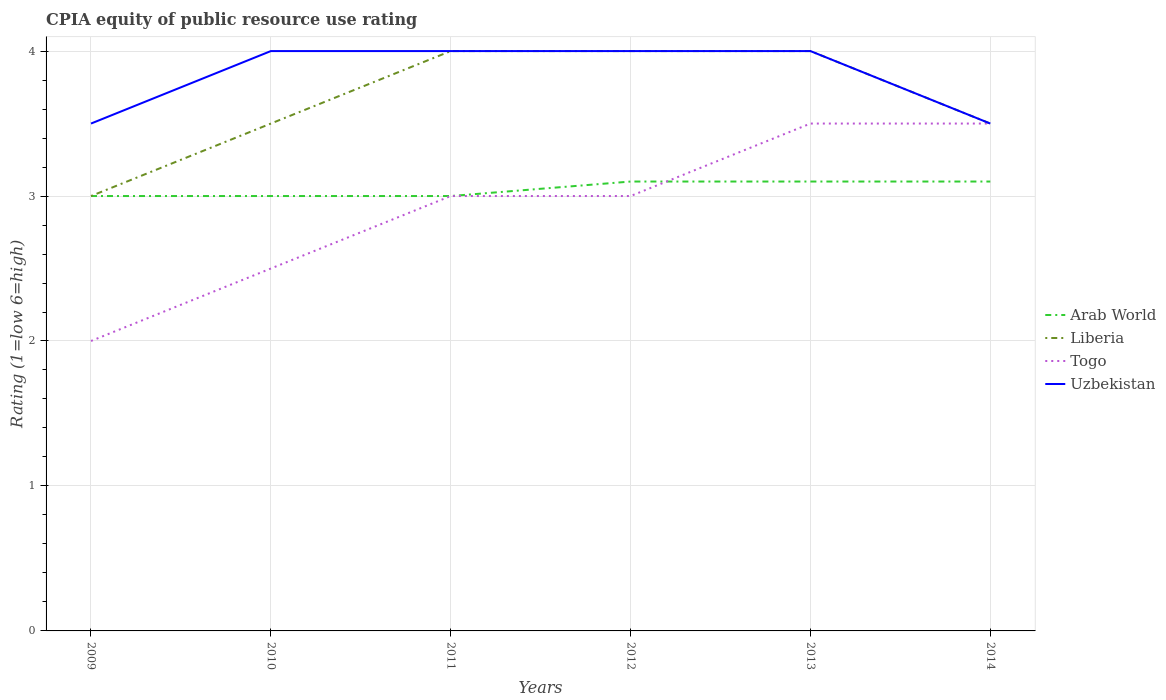How many different coloured lines are there?
Your response must be concise. 4. Does the line corresponding to Arab World intersect with the line corresponding to Uzbekistan?
Give a very brief answer. No. Is the number of lines equal to the number of legend labels?
Provide a short and direct response. Yes. In which year was the CPIA rating in Arab World maximum?
Keep it short and to the point. 2009. What is the total CPIA rating in Arab World in the graph?
Provide a succinct answer. -0.1. What is the difference between the highest and the second highest CPIA rating in Arab World?
Make the answer very short. 0.1. Is the CPIA rating in Liberia strictly greater than the CPIA rating in Togo over the years?
Give a very brief answer. No. How many lines are there?
Your answer should be compact. 4. What is the difference between two consecutive major ticks on the Y-axis?
Provide a succinct answer. 1. Are the values on the major ticks of Y-axis written in scientific E-notation?
Your response must be concise. No. Does the graph contain any zero values?
Offer a terse response. No. Does the graph contain grids?
Give a very brief answer. Yes. How many legend labels are there?
Give a very brief answer. 4. How are the legend labels stacked?
Provide a short and direct response. Vertical. What is the title of the graph?
Provide a succinct answer. CPIA equity of public resource use rating. Does "El Salvador" appear as one of the legend labels in the graph?
Give a very brief answer. No. What is the label or title of the Y-axis?
Your answer should be compact. Rating (1=low 6=high). What is the Rating (1=low 6=high) in Arab World in 2009?
Make the answer very short. 3. What is the Rating (1=low 6=high) of Liberia in 2009?
Make the answer very short. 3. What is the Rating (1=low 6=high) in Arab World in 2010?
Give a very brief answer. 3. What is the Rating (1=low 6=high) of Liberia in 2010?
Your response must be concise. 3.5. What is the Rating (1=low 6=high) in Togo in 2010?
Make the answer very short. 2.5. What is the Rating (1=low 6=high) of Liberia in 2011?
Offer a terse response. 4. What is the Rating (1=low 6=high) in Uzbekistan in 2011?
Make the answer very short. 4. What is the Rating (1=low 6=high) in Arab World in 2012?
Ensure brevity in your answer.  3.1. What is the Rating (1=low 6=high) of Togo in 2012?
Make the answer very short. 3. What is the Rating (1=low 6=high) of Arab World in 2013?
Offer a terse response. 3.1. What is the Rating (1=low 6=high) of Liberia in 2013?
Keep it short and to the point. 4. What is the Rating (1=low 6=high) of Liberia in 2014?
Provide a succinct answer. 3.5. What is the Rating (1=low 6=high) of Uzbekistan in 2014?
Offer a very short reply. 3.5. Across all years, what is the maximum Rating (1=low 6=high) of Liberia?
Offer a very short reply. 4. Across all years, what is the minimum Rating (1=low 6=high) of Arab World?
Offer a very short reply. 3. Across all years, what is the minimum Rating (1=low 6=high) in Togo?
Your answer should be very brief. 2. Across all years, what is the minimum Rating (1=low 6=high) in Uzbekistan?
Offer a terse response. 3.5. What is the total Rating (1=low 6=high) of Arab World in the graph?
Your answer should be compact. 18.3. What is the total Rating (1=low 6=high) of Liberia in the graph?
Your answer should be very brief. 22. What is the difference between the Rating (1=low 6=high) in Liberia in 2009 and that in 2010?
Your answer should be compact. -0.5. What is the difference between the Rating (1=low 6=high) in Togo in 2009 and that in 2010?
Keep it short and to the point. -0.5. What is the difference between the Rating (1=low 6=high) of Uzbekistan in 2009 and that in 2010?
Your answer should be compact. -0.5. What is the difference between the Rating (1=low 6=high) in Liberia in 2009 and that in 2011?
Offer a very short reply. -1. What is the difference between the Rating (1=low 6=high) in Arab World in 2009 and that in 2012?
Give a very brief answer. -0.1. What is the difference between the Rating (1=low 6=high) of Liberia in 2009 and that in 2012?
Make the answer very short. -1. What is the difference between the Rating (1=low 6=high) in Uzbekistan in 2009 and that in 2012?
Provide a short and direct response. -0.5. What is the difference between the Rating (1=low 6=high) in Arab World in 2009 and that in 2013?
Provide a short and direct response. -0.1. What is the difference between the Rating (1=low 6=high) of Liberia in 2009 and that in 2014?
Make the answer very short. -0.5. What is the difference between the Rating (1=low 6=high) of Togo in 2009 and that in 2014?
Give a very brief answer. -1.5. What is the difference between the Rating (1=low 6=high) of Arab World in 2010 and that in 2011?
Provide a succinct answer. 0. What is the difference between the Rating (1=low 6=high) of Liberia in 2010 and that in 2011?
Make the answer very short. -0.5. What is the difference between the Rating (1=low 6=high) in Togo in 2010 and that in 2011?
Your answer should be very brief. -0.5. What is the difference between the Rating (1=low 6=high) of Uzbekistan in 2010 and that in 2011?
Your response must be concise. 0. What is the difference between the Rating (1=low 6=high) of Liberia in 2010 and that in 2012?
Provide a succinct answer. -0.5. What is the difference between the Rating (1=low 6=high) in Togo in 2010 and that in 2012?
Provide a short and direct response. -0.5. What is the difference between the Rating (1=low 6=high) in Uzbekistan in 2010 and that in 2012?
Your answer should be compact. 0. What is the difference between the Rating (1=low 6=high) in Arab World in 2010 and that in 2013?
Provide a short and direct response. -0.1. What is the difference between the Rating (1=low 6=high) in Liberia in 2010 and that in 2013?
Keep it short and to the point. -0.5. What is the difference between the Rating (1=low 6=high) of Uzbekistan in 2010 and that in 2013?
Offer a terse response. 0. What is the difference between the Rating (1=low 6=high) in Arab World in 2010 and that in 2014?
Keep it short and to the point. -0.1. What is the difference between the Rating (1=low 6=high) in Uzbekistan in 2010 and that in 2014?
Ensure brevity in your answer.  0.5. What is the difference between the Rating (1=low 6=high) of Togo in 2011 and that in 2012?
Provide a succinct answer. 0. What is the difference between the Rating (1=low 6=high) of Liberia in 2011 and that in 2013?
Provide a succinct answer. 0. What is the difference between the Rating (1=low 6=high) of Togo in 2011 and that in 2013?
Keep it short and to the point. -0.5. What is the difference between the Rating (1=low 6=high) of Arab World in 2011 and that in 2014?
Offer a very short reply. -0.1. What is the difference between the Rating (1=low 6=high) in Arab World in 2012 and that in 2013?
Your answer should be very brief. 0. What is the difference between the Rating (1=low 6=high) of Liberia in 2012 and that in 2013?
Offer a terse response. 0. What is the difference between the Rating (1=low 6=high) of Togo in 2012 and that in 2013?
Your response must be concise. -0.5. What is the difference between the Rating (1=low 6=high) of Arab World in 2012 and that in 2014?
Your response must be concise. 0. What is the difference between the Rating (1=low 6=high) in Liberia in 2012 and that in 2014?
Make the answer very short. 0.5. What is the difference between the Rating (1=low 6=high) of Togo in 2012 and that in 2014?
Provide a succinct answer. -0.5. What is the difference between the Rating (1=low 6=high) of Arab World in 2013 and that in 2014?
Your answer should be very brief. 0. What is the difference between the Rating (1=low 6=high) of Togo in 2013 and that in 2014?
Provide a short and direct response. 0. What is the difference between the Rating (1=low 6=high) of Arab World in 2009 and the Rating (1=low 6=high) of Liberia in 2011?
Ensure brevity in your answer.  -1. What is the difference between the Rating (1=low 6=high) of Arab World in 2009 and the Rating (1=low 6=high) of Uzbekistan in 2011?
Make the answer very short. -1. What is the difference between the Rating (1=low 6=high) of Liberia in 2009 and the Rating (1=low 6=high) of Togo in 2011?
Offer a terse response. 0. What is the difference between the Rating (1=low 6=high) of Togo in 2009 and the Rating (1=low 6=high) of Uzbekistan in 2011?
Provide a short and direct response. -2. What is the difference between the Rating (1=low 6=high) in Arab World in 2009 and the Rating (1=low 6=high) in Togo in 2012?
Your answer should be very brief. 0. What is the difference between the Rating (1=low 6=high) in Arab World in 2009 and the Rating (1=low 6=high) in Uzbekistan in 2012?
Offer a very short reply. -1. What is the difference between the Rating (1=low 6=high) in Liberia in 2009 and the Rating (1=low 6=high) in Uzbekistan in 2012?
Your answer should be compact. -1. What is the difference between the Rating (1=low 6=high) of Togo in 2009 and the Rating (1=low 6=high) of Uzbekistan in 2012?
Ensure brevity in your answer.  -2. What is the difference between the Rating (1=low 6=high) in Arab World in 2009 and the Rating (1=low 6=high) in Liberia in 2013?
Ensure brevity in your answer.  -1. What is the difference between the Rating (1=low 6=high) in Liberia in 2009 and the Rating (1=low 6=high) in Togo in 2013?
Your answer should be very brief. -0.5. What is the difference between the Rating (1=low 6=high) of Liberia in 2009 and the Rating (1=low 6=high) of Uzbekistan in 2013?
Offer a very short reply. -1. What is the difference between the Rating (1=low 6=high) of Togo in 2009 and the Rating (1=low 6=high) of Uzbekistan in 2013?
Give a very brief answer. -2. What is the difference between the Rating (1=low 6=high) in Arab World in 2009 and the Rating (1=low 6=high) in Liberia in 2014?
Your answer should be compact. -0.5. What is the difference between the Rating (1=low 6=high) of Arab World in 2009 and the Rating (1=low 6=high) of Togo in 2014?
Your response must be concise. -0.5. What is the difference between the Rating (1=low 6=high) of Arab World in 2009 and the Rating (1=low 6=high) of Uzbekistan in 2014?
Make the answer very short. -0.5. What is the difference between the Rating (1=low 6=high) in Arab World in 2010 and the Rating (1=low 6=high) in Togo in 2011?
Provide a succinct answer. 0. What is the difference between the Rating (1=low 6=high) in Arab World in 2010 and the Rating (1=low 6=high) in Uzbekistan in 2011?
Keep it short and to the point. -1. What is the difference between the Rating (1=low 6=high) of Liberia in 2010 and the Rating (1=low 6=high) of Uzbekistan in 2011?
Provide a short and direct response. -0.5. What is the difference between the Rating (1=low 6=high) of Arab World in 2010 and the Rating (1=low 6=high) of Liberia in 2012?
Offer a very short reply. -1. What is the difference between the Rating (1=low 6=high) in Arab World in 2010 and the Rating (1=low 6=high) in Uzbekistan in 2012?
Your answer should be compact. -1. What is the difference between the Rating (1=low 6=high) in Togo in 2010 and the Rating (1=low 6=high) in Uzbekistan in 2012?
Keep it short and to the point. -1.5. What is the difference between the Rating (1=low 6=high) of Liberia in 2010 and the Rating (1=low 6=high) of Uzbekistan in 2013?
Keep it short and to the point. -0.5. What is the difference between the Rating (1=low 6=high) in Arab World in 2010 and the Rating (1=low 6=high) in Liberia in 2014?
Your answer should be compact. -0.5. What is the difference between the Rating (1=low 6=high) of Arab World in 2010 and the Rating (1=low 6=high) of Uzbekistan in 2014?
Make the answer very short. -0.5. What is the difference between the Rating (1=low 6=high) of Liberia in 2010 and the Rating (1=low 6=high) of Uzbekistan in 2014?
Your response must be concise. 0. What is the difference between the Rating (1=low 6=high) in Togo in 2010 and the Rating (1=low 6=high) in Uzbekistan in 2014?
Your answer should be very brief. -1. What is the difference between the Rating (1=low 6=high) of Arab World in 2011 and the Rating (1=low 6=high) of Togo in 2012?
Offer a very short reply. 0. What is the difference between the Rating (1=low 6=high) of Liberia in 2011 and the Rating (1=low 6=high) of Togo in 2012?
Ensure brevity in your answer.  1. What is the difference between the Rating (1=low 6=high) of Liberia in 2011 and the Rating (1=low 6=high) of Uzbekistan in 2012?
Make the answer very short. 0. What is the difference between the Rating (1=low 6=high) in Arab World in 2011 and the Rating (1=low 6=high) in Togo in 2013?
Provide a short and direct response. -0.5. What is the difference between the Rating (1=low 6=high) of Arab World in 2011 and the Rating (1=low 6=high) of Liberia in 2014?
Offer a terse response. -0.5. What is the difference between the Rating (1=low 6=high) in Arab World in 2011 and the Rating (1=low 6=high) in Uzbekistan in 2014?
Offer a terse response. -0.5. What is the difference between the Rating (1=low 6=high) in Liberia in 2011 and the Rating (1=low 6=high) in Uzbekistan in 2014?
Provide a succinct answer. 0.5. What is the difference between the Rating (1=low 6=high) of Togo in 2012 and the Rating (1=low 6=high) of Uzbekistan in 2013?
Keep it short and to the point. -1. What is the difference between the Rating (1=low 6=high) in Arab World in 2012 and the Rating (1=low 6=high) in Liberia in 2014?
Your answer should be very brief. -0.4. What is the difference between the Rating (1=low 6=high) in Arab World in 2012 and the Rating (1=low 6=high) in Uzbekistan in 2014?
Offer a very short reply. -0.4. What is the difference between the Rating (1=low 6=high) in Arab World in 2013 and the Rating (1=low 6=high) in Togo in 2014?
Your answer should be very brief. -0.4. What is the difference between the Rating (1=low 6=high) of Arab World in 2013 and the Rating (1=low 6=high) of Uzbekistan in 2014?
Offer a very short reply. -0.4. What is the difference between the Rating (1=low 6=high) of Liberia in 2013 and the Rating (1=low 6=high) of Uzbekistan in 2014?
Provide a succinct answer. 0.5. What is the difference between the Rating (1=low 6=high) of Togo in 2013 and the Rating (1=low 6=high) of Uzbekistan in 2014?
Keep it short and to the point. 0. What is the average Rating (1=low 6=high) of Arab World per year?
Give a very brief answer. 3.05. What is the average Rating (1=low 6=high) of Liberia per year?
Ensure brevity in your answer.  3.67. What is the average Rating (1=low 6=high) in Togo per year?
Your answer should be very brief. 2.92. What is the average Rating (1=low 6=high) in Uzbekistan per year?
Provide a short and direct response. 3.83. In the year 2009, what is the difference between the Rating (1=low 6=high) in Arab World and Rating (1=low 6=high) in Uzbekistan?
Ensure brevity in your answer.  -0.5. In the year 2009, what is the difference between the Rating (1=low 6=high) in Liberia and Rating (1=low 6=high) in Togo?
Ensure brevity in your answer.  1. In the year 2010, what is the difference between the Rating (1=low 6=high) of Arab World and Rating (1=low 6=high) of Togo?
Ensure brevity in your answer.  0.5. In the year 2010, what is the difference between the Rating (1=low 6=high) in Arab World and Rating (1=low 6=high) in Uzbekistan?
Keep it short and to the point. -1. In the year 2010, what is the difference between the Rating (1=low 6=high) of Liberia and Rating (1=low 6=high) of Uzbekistan?
Your response must be concise. -0.5. In the year 2011, what is the difference between the Rating (1=low 6=high) in Liberia and Rating (1=low 6=high) in Togo?
Give a very brief answer. 1. In the year 2011, what is the difference between the Rating (1=low 6=high) in Liberia and Rating (1=low 6=high) in Uzbekistan?
Make the answer very short. 0. In the year 2012, what is the difference between the Rating (1=low 6=high) in Arab World and Rating (1=low 6=high) in Liberia?
Ensure brevity in your answer.  -0.9. In the year 2012, what is the difference between the Rating (1=low 6=high) in Arab World and Rating (1=low 6=high) in Togo?
Keep it short and to the point. 0.1. In the year 2012, what is the difference between the Rating (1=low 6=high) of Togo and Rating (1=low 6=high) of Uzbekistan?
Your answer should be very brief. -1. In the year 2013, what is the difference between the Rating (1=low 6=high) of Arab World and Rating (1=low 6=high) of Togo?
Provide a short and direct response. -0.4. In the year 2013, what is the difference between the Rating (1=low 6=high) in Arab World and Rating (1=low 6=high) in Uzbekistan?
Your response must be concise. -0.9. In the year 2013, what is the difference between the Rating (1=low 6=high) of Liberia and Rating (1=low 6=high) of Togo?
Give a very brief answer. 0.5. In the year 2013, what is the difference between the Rating (1=low 6=high) of Togo and Rating (1=low 6=high) of Uzbekistan?
Ensure brevity in your answer.  -0.5. In the year 2014, what is the difference between the Rating (1=low 6=high) in Arab World and Rating (1=low 6=high) in Liberia?
Offer a very short reply. -0.4. In the year 2014, what is the difference between the Rating (1=low 6=high) in Togo and Rating (1=low 6=high) in Uzbekistan?
Your response must be concise. 0. What is the ratio of the Rating (1=low 6=high) in Arab World in 2009 to that in 2010?
Your answer should be very brief. 1. What is the ratio of the Rating (1=low 6=high) of Liberia in 2009 to that in 2010?
Offer a very short reply. 0.86. What is the ratio of the Rating (1=low 6=high) in Togo in 2009 to that in 2010?
Ensure brevity in your answer.  0.8. What is the ratio of the Rating (1=low 6=high) of Uzbekistan in 2009 to that in 2010?
Your answer should be very brief. 0.88. What is the ratio of the Rating (1=low 6=high) in Arab World in 2009 to that in 2011?
Keep it short and to the point. 1. What is the ratio of the Rating (1=low 6=high) in Liberia in 2009 to that in 2011?
Offer a terse response. 0.75. What is the ratio of the Rating (1=low 6=high) of Togo in 2009 to that in 2011?
Your answer should be compact. 0.67. What is the ratio of the Rating (1=low 6=high) of Arab World in 2009 to that in 2012?
Keep it short and to the point. 0.97. What is the ratio of the Rating (1=low 6=high) in Liberia in 2009 to that in 2012?
Keep it short and to the point. 0.75. What is the ratio of the Rating (1=low 6=high) in Arab World in 2009 to that in 2013?
Make the answer very short. 0.97. What is the ratio of the Rating (1=low 6=high) in Uzbekistan in 2009 to that in 2013?
Give a very brief answer. 0.88. What is the ratio of the Rating (1=low 6=high) of Togo in 2009 to that in 2014?
Your response must be concise. 0.57. What is the ratio of the Rating (1=low 6=high) of Togo in 2010 to that in 2011?
Offer a very short reply. 0.83. What is the ratio of the Rating (1=low 6=high) in Arab World in 2010 to that in 2012?
Your answer should be very brief. 0.97. What is the ratio of the Rating (1=low 6=high) of Liberia in 2010 to that in 2012?
Offer a terse response. 0.88. What is the ratio of the Rating (1=low 6=high) in Togo in 2010 to that in 2012?
Ensure brevity in your answer.  0.83. What is the ratio of the Rating (1=low 6=high) of Uzbekistan in 2010 to that in 2012?
Give a very brief answer. 1. What is the ratio of the Rating (1=low 6=high) of Arab World in 2010 to that in 2013?
Make the answer very short. 0.97. What is the ratio of the Rating (1=low 6=high) in Arab World in 2010 to that in 2014?
Your answer should be very brief. 0.97. What is the ratio of the Rating (1=low 6=high) in Arab World in 2011 to that in 2013?
Provide a short and direct response. 0.97. What is the ratio of the Rating (1=low 6=high) of Togo in 2011 to that in 2013?
Provide a short and direct response. 0.86. What is the ratio of the Rating (1=low 6=high) of Uzbekistan in 2011 to that in 2013?
Make the answer very short. 1. What is the ratio of the Rating (1=low 6=high) of Liberia in 2011 to that in 2014?
Keep it short and to the point. 1.14. What is the ratio of the Rating (1=low 6=high) in Togo in 2011 to that in 2014?
Give a very brief answer. 0.86. What is the ratio of the Rating (1=low 6=high) in Uzbekistan in 2011 to that in 2014?
Offer a very short reply. 1.14. What is the ratio of the Rating (1=low 6=high) in Liberia in 2012 to that in 2013?
Provide a short and direct response. 1. What is the ratio of the Rating (1=low 6=high) in Togo in 2012 to that in 2013?
Provide a succinct answer. 0.86. What is the ratio of the Rating (1=low 6=high) of Uzbekistan in 2012 to that in 2013?
Keep it short and to the point. 1. What is the ratio of the Rating (1=low 6=high) in Liberia in 2013 to that in 2014?
Make the answer very short. 1.14. What is the ratio of the Rating (1=low 6=high) of Uzbekistan in 2013 to that in 2014?
Your response must be concise. 1.14. What is the difference between the highest and the second highest Rating (1=low 6=high) in Arab World?
Your answer should be compact. 0. What is the difference between the highest and the lowest Rating (1=low 6=high) of Arab World?
Provide a short and direct response. 0.1. What is the difference between the highest and the lowest Rating (1=low 6=high) in Liberia?
Your answer should be very brief. 1. What is the difference between the highest and the lowest Rating (1=low 6=high) in Togo?
Your answer should be compact. 1.5. What is the difference between the highest and the lowest Rating (1=low 6=high) in Uzbekistan?
Give a very brief answer. 0.5. 